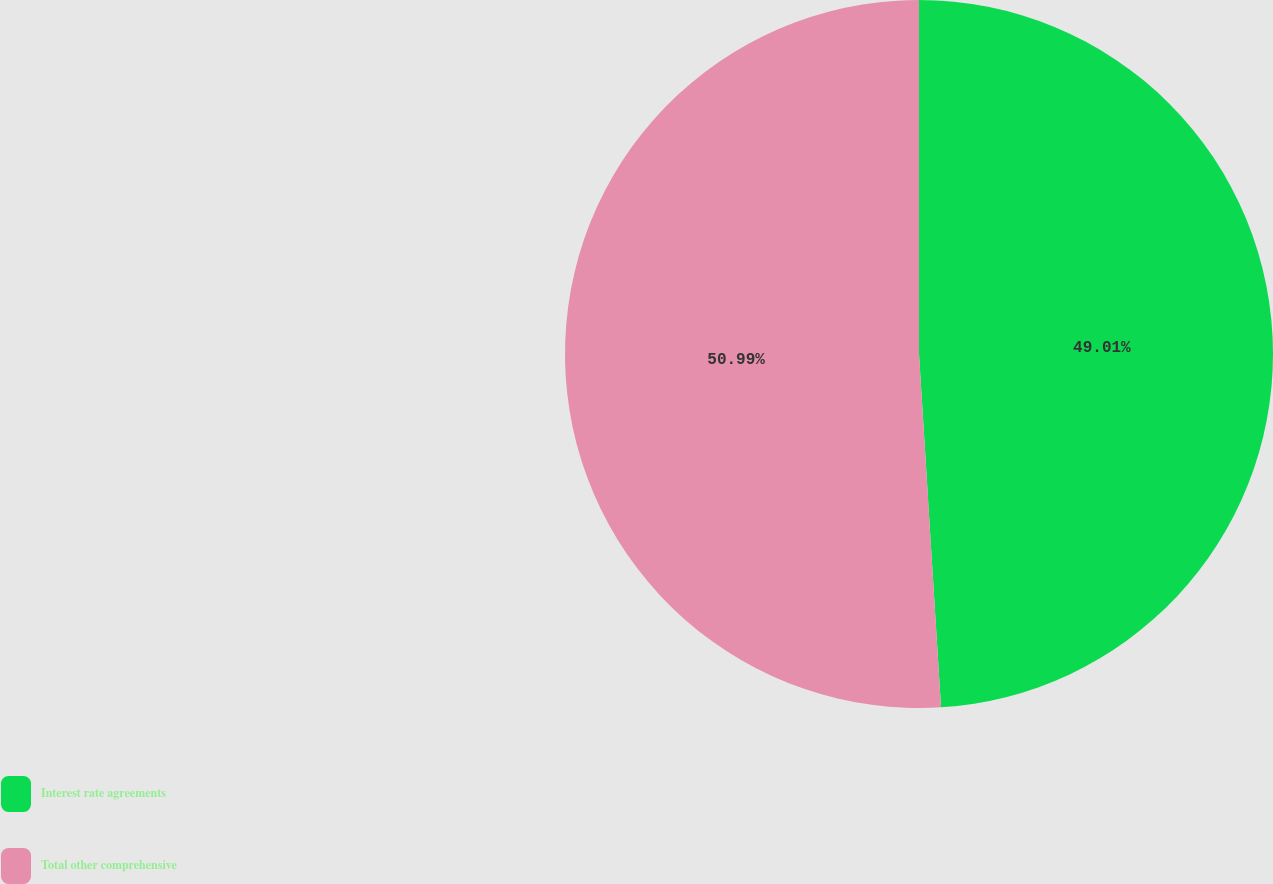Convert chart. <chart><loc_0><loc_0><loc_500><loc_500><pie_chart><fcel>Interest rate agreements<fcel>Total other comprehensive<nl><fcel>49.01%<fcel>50.99%<nl></chart> 